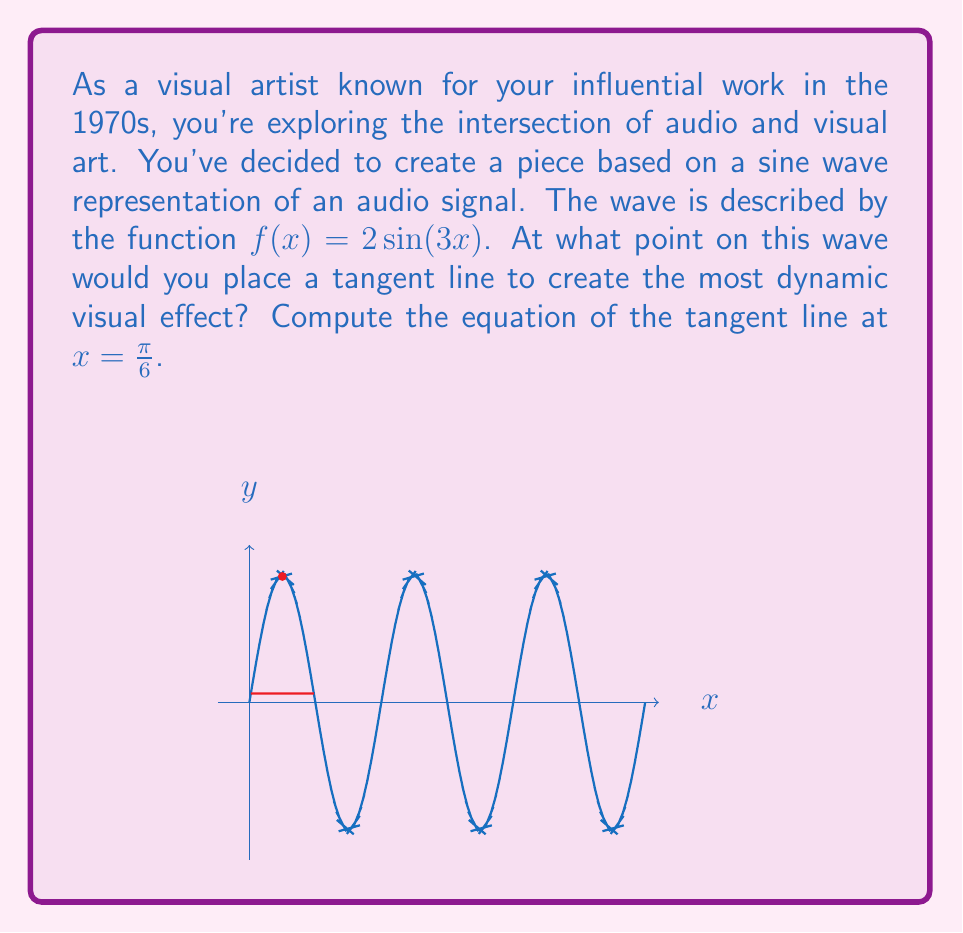Can you solve this math problem? Let's approach this step-by-step:

1) The function is $f(x) = 2\sin(3x)$

2) To find the tangent line, we need the slope at the point $x = \frac{\pi}{6}$. This is given by the derivative of $f(x)$ at that point.

3) Let's find the derivative $f'(x)$:
   $$f'(x) = 2 \cdot 3 \cos(3x) = 6\cos(3x)$$

4) Now, we evaluate $f'(\frac{\pi}{6})$:
   $$f'(\frac{\pi}{6}) = 6\cos(3 \cdot \frac{\pi}{6}) = 6\cos(\frac{\pi}{2}) = 6 \cdot 0 = 0$$

5) We also need the y-coordinate of the point. Let's calculate $f(\frac{\pi}{6})$:
   $$f(\frac{\pi}{6}) = 2\sin(3 \cdot \frac{\pi}{6}) = 2\sin(\frac{\pi}{2}) = 2 \cdot 1 = 2$$

6) So, our point is $(\frac{\pi}{6}, 2)$

7) The equation of a tangent line is $y - y_1 = m(x - x_1)$, where $m$ is the slope (which we found to be 0).

8) Plugging in our values:
   $$y - 2 = 0(x - \frac{\pi}{6})$$

9) Simplifying:
   $$y = 2$$

This is the equation of a horizontal line passing through the point $(\frac{\pi}{6}, 2)$.
Answer: $y = 2$ 